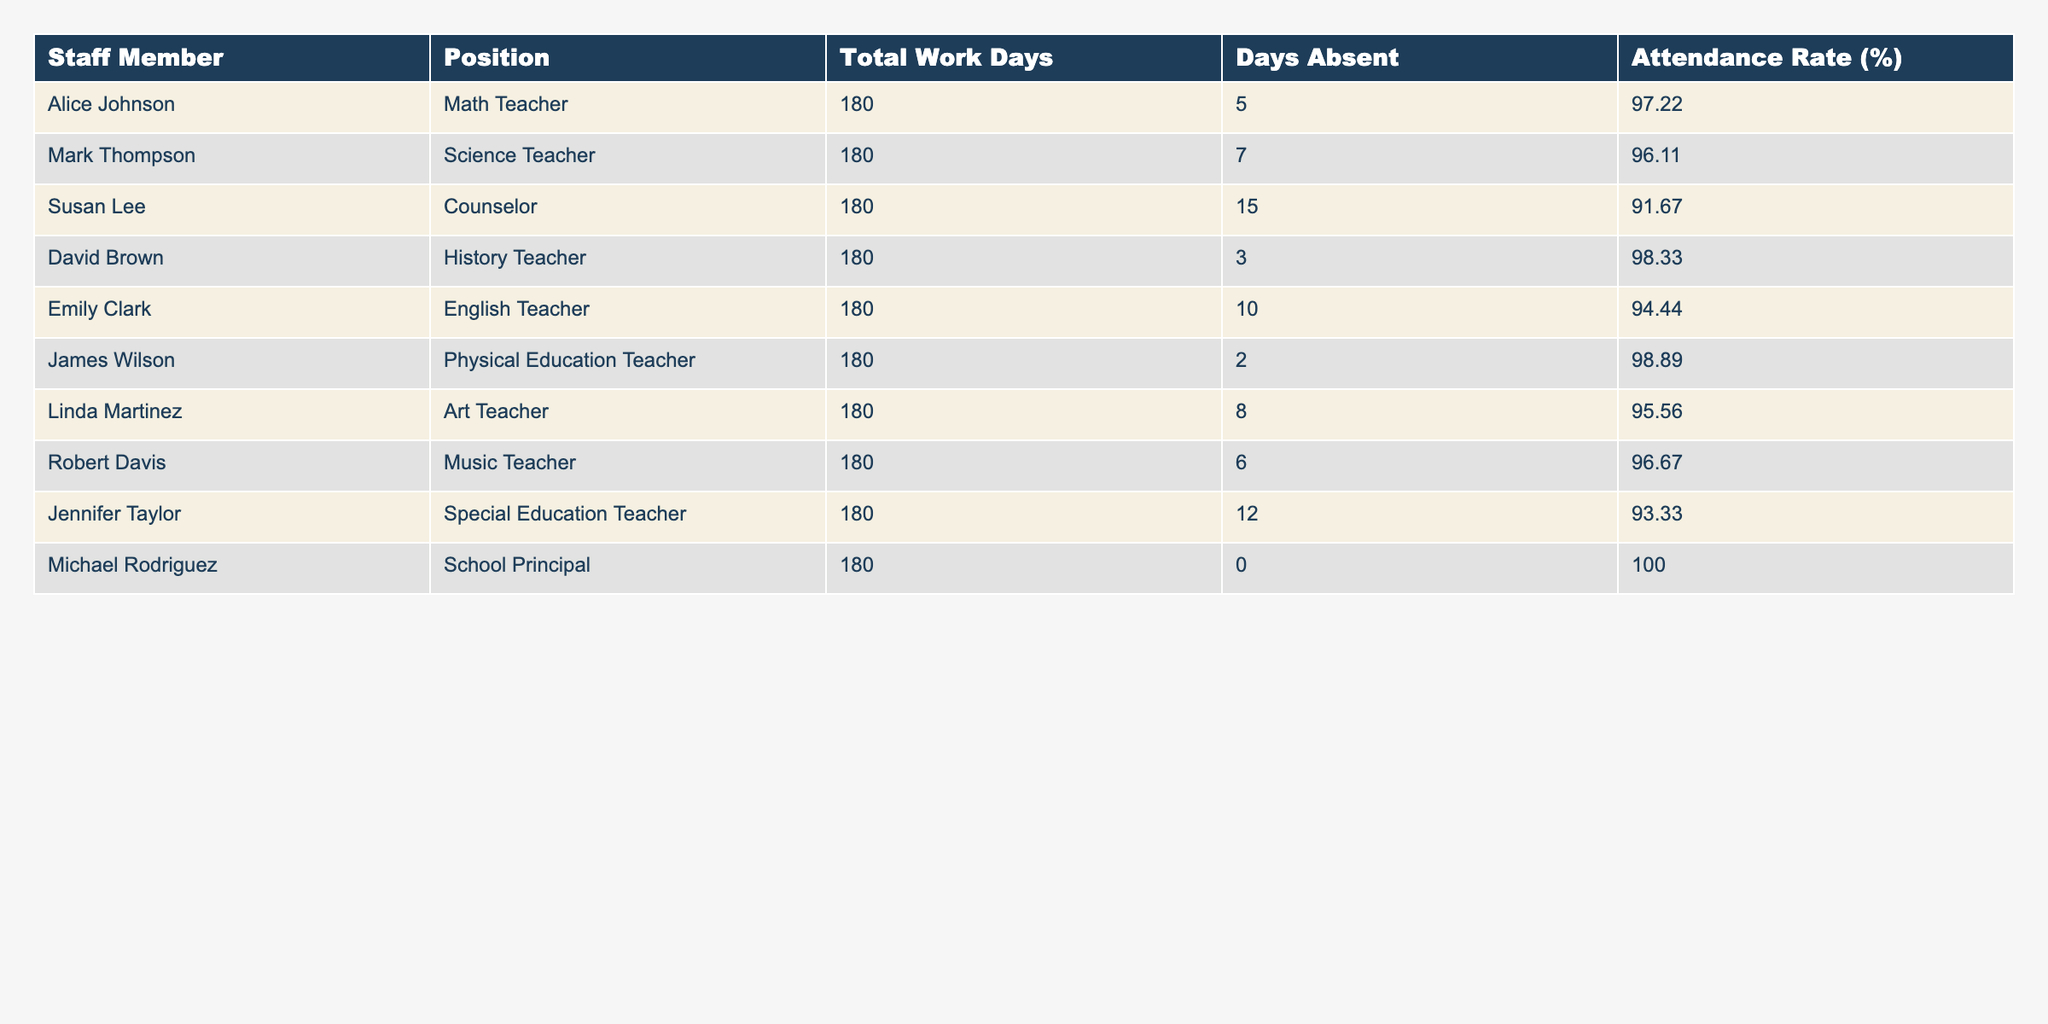What is the attendance rate of the School Principal? According to the table, the attendance rate for Michael Rodriguez, the School Principal, is listed as 100.00%.
Answer: 100.00% Which staff member has the lowest attendance rate? The lowest attendance rate is found in the row for Susan Lee, the Counselor, which is 91.67%.
Answer: Susan Lee How many total work days did James Wilson have? From the table, it's clear that James Wilson, who is a Physical Education Teacher, had a total of 180 work days.
Answer: 180 What is the average attendance rate of all staff members? To find the average attendance rate, we sum the attendance rates: 97.22 + 96.11 + 91.67 + 98.33 + 94.44 + 98.89 + 95.56 + 96.67 + 93.33 + 100.00 =  1000.22. There are 10 staff members, so the average is 1000.22 / 10 = 100.022.
Answer: 100.022 Is Emily Clark's attendance rate above 95%? Emily Clark has an attendance rate of 94.44%, which is below 95%. Therefore, the answer is no.
Answer: No What percentage of days did David Brown miss compared to total work days? David Brown was absent for 3 days out of 180 work days. To find the percentage, we calculate (3 / 180) * 100 = 1.67%.
Answer: 1.67% How many days did Robert Davis miss compared to Mark Thompson? Robert Davis missed 6 days, while Mark Thompson missed 7 days. The difference is 7 - 6 = 1 day, meaning Mark Thompson missed 1 more day than Robert Davis.
Answer: 1 day Which position has the highest attendance rate? Upon examining the attendance rates in the table, Michael Rodriguez, the School Principal, has the highest attendance rate of 100%.
Answer: School Principal How do Susan Lee's absences compare to James Wilson's? Susan Lee was absent for 15 days, while James Wilson was only absent for 2 days. This shows that Susan Lee had 15 - 2 = 13 more absences than James Wilson.
Answer: 13 more absences 